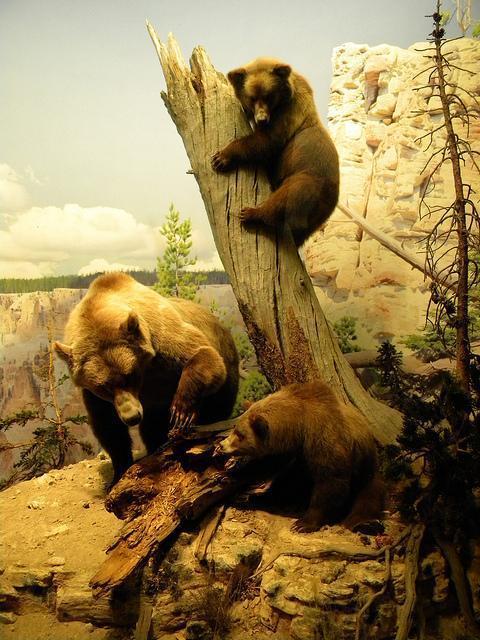How many bears are in the photo?
Give a very brief answer. 3. How many bears in the tree?
Give a very brief answer. 1. How many animals are shown?
Give a very brief answer. 3. How many bears can you see?
Give a very brief answer. 3. How many people are there?
Give a very brief answer. 0. 